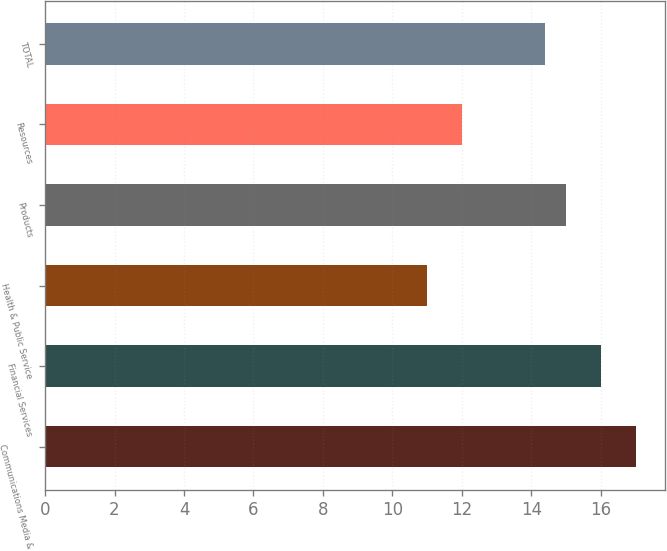Convert chart. <chart><loc_0><loc_0><loc_500><loc_500><bar_chart><fcel>Communications Media &<fcel>Financial Services<fcel>Health & Public Service<fcel>Products<fcel>Resources<fcel>TOTAL<nl><fcel>17<fcel>16<fcel>11<fcel>15<fcel>12<fcel>14.4<nl></chart> 